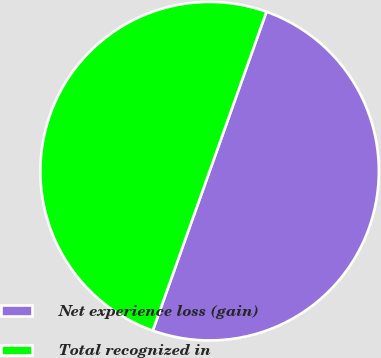<chart> <loc_0><loc_0><loc_500><loc_500><pie_chart><fcel>Net experience loss (gain)<fcel>Total recognized in<nl><fcel>50.0%<fcel>50.0%<nl></chart> 